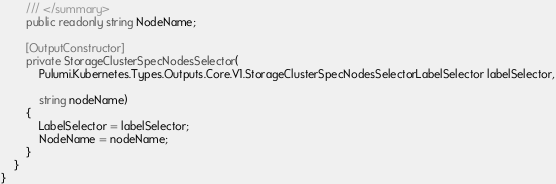Convert code to text. <code><loc_0><loc_0><loc_500><loc_500><_C#_>        /// </summary>
        public readonly string NodeName;

        [OutputConstructor]
        private StorageClusterSpecNodesSelector(
            Pulumi.Kubernetes.Types.Outputs.Core.V1.StorageClusterSpecNodesSelectorLabelSelector labelSelector,

            string nodeName)
        {
            LabelSelector = labelSelector;
            NodeName = nodeName;
        }
    }
}
</code> 